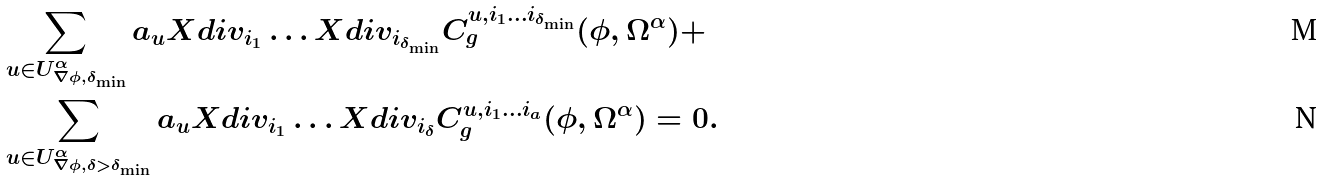Convert formula to latex. <formula><loc_0><loc_0><loc_500><loc_500>& \sum _ { u \in U ^ { \alpha } _ { \nabla \phi , \delta _ { \min } } } a _ { u } X d i v _ { i _ { 1 } } \dots X d i v _ { i _ { \delta _ { \min } } } C ^ { u , i _ { 1 } \dots i _ { \delta _ { \min } } } _ { g } ( \phi , \Omega ^ { \alpha } ) + \\ & \sum _ { u \in U ^ { \alpha } _ { \nabla \phi , \delta > \delta _ { \min } } } a _ { u } X d i v _ { i _ { 1 } } \dots X d i v _ { i _ { \delta } } C ^ { u , i _ { 1 } \dots i _ { a } } _ { g } ( \phi , \Omega ^ { \alpha } ) = 0 .</formula> 